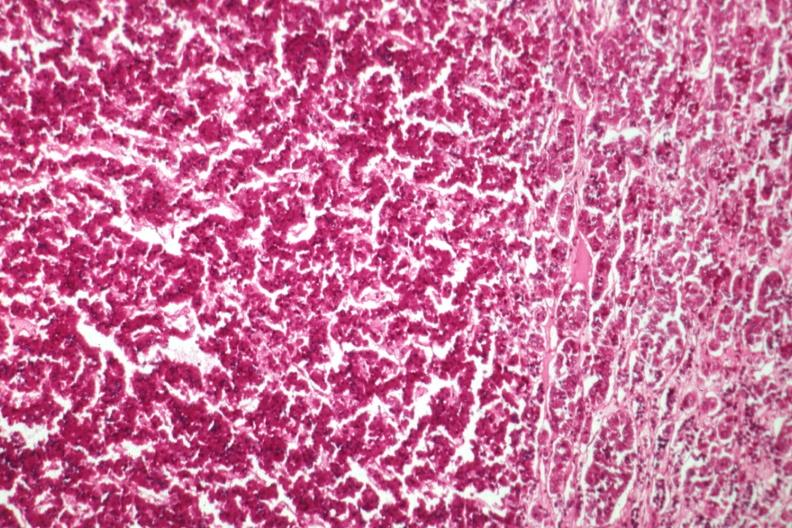s endocrine present?
Answer the question using a single word or phrase. Yes 